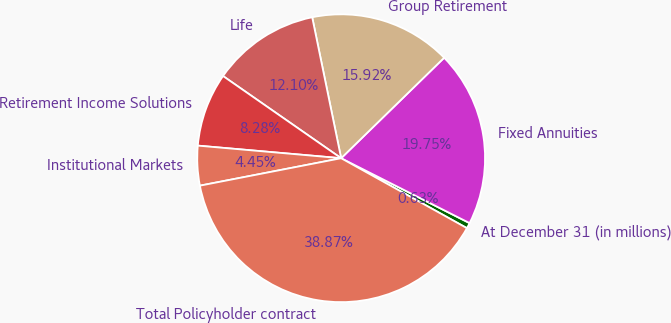Convert chart to OTSL. <chart><loc_0><loc_0><loc_500><loc_500><pie_chart><fcel>At December 31 (in millions)<fcel>Fixed Annuities<fcel>Group Retirement<fcel>Life<fcel>Retirement Income Solutions<fcel>Institutional Markets<fcel>Total Policyholder contract<nl><fcel>0.63%<fcel>19.75%<fcel>15.92%<fcel>12.1%<fcel>8.28%<fcel>4.45%<fcel>38.87%<nl></chart> 